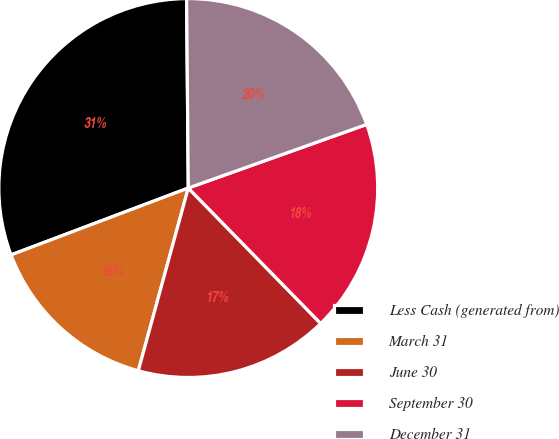<chart> <loc_0><loc_0><loc_500><loc_500><pie_chart><fcel>Less Cash (generated from)<fcel>March 31<fcel>June 30<fcel>September 30<fcel>December 31<nl><fcel>30.6%<fcel>15.01%<fcel>16.57%<fcel>18.13%<fcel>19.69%<nl></chart> 